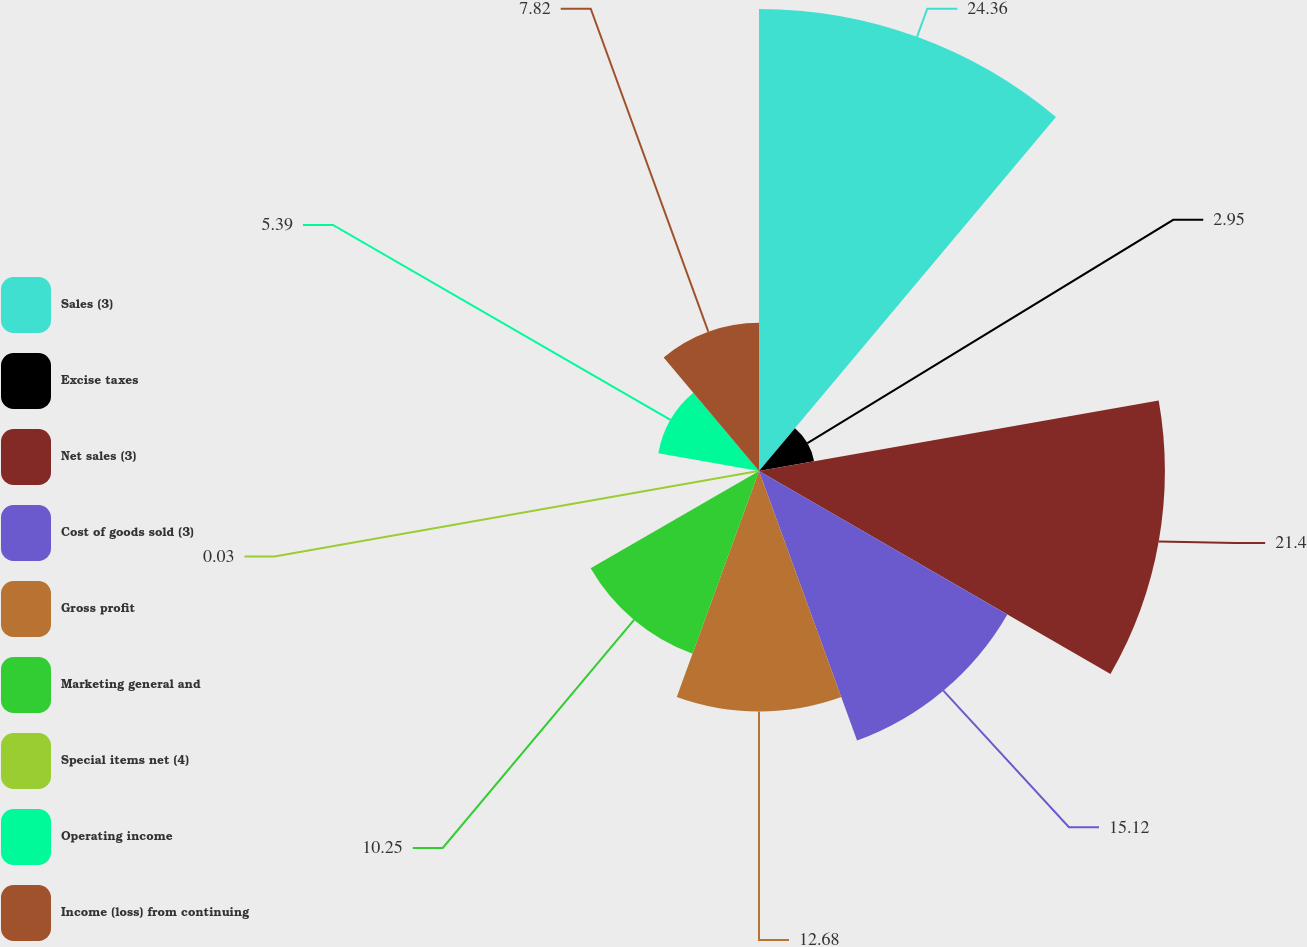<chart> <loc_0><loc_0><loc_500><loc_500><pie_chart><fcel>Sales (3)<fcel>Excise taxes<fcel>Net sales (3)<fcel>Cost of goods sold (3)<fcel>Gross profit<fcel>Marketing general and<fcel>Special items net (4)<fcel>Operating income<fcel>Income (loss) from continuing<nl><fcel>24.36%<fcel>2.95%<fcel>21.4%<fcel>15.12%<fcel>12.68%<fcel>10.25%<fcel>0.03%<fcel>5.39%<fcel>7.82%<nl></chart> 